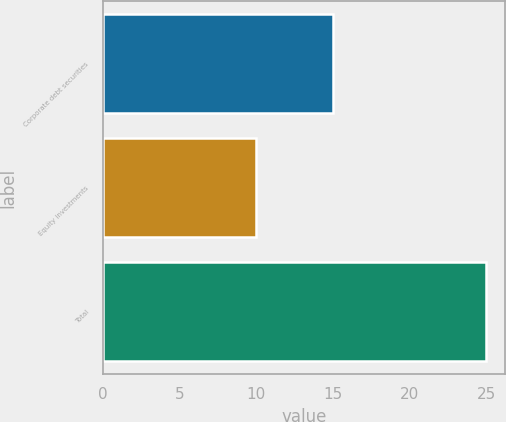<chart> <loc_0><loc_0><loc_500><loc_500><bar_chart><fcel>Corporate debt securities<fcel>Equity investments<fcel>Total<nl><fcel>15<fcel>10<fcel>25<nl></chart> 